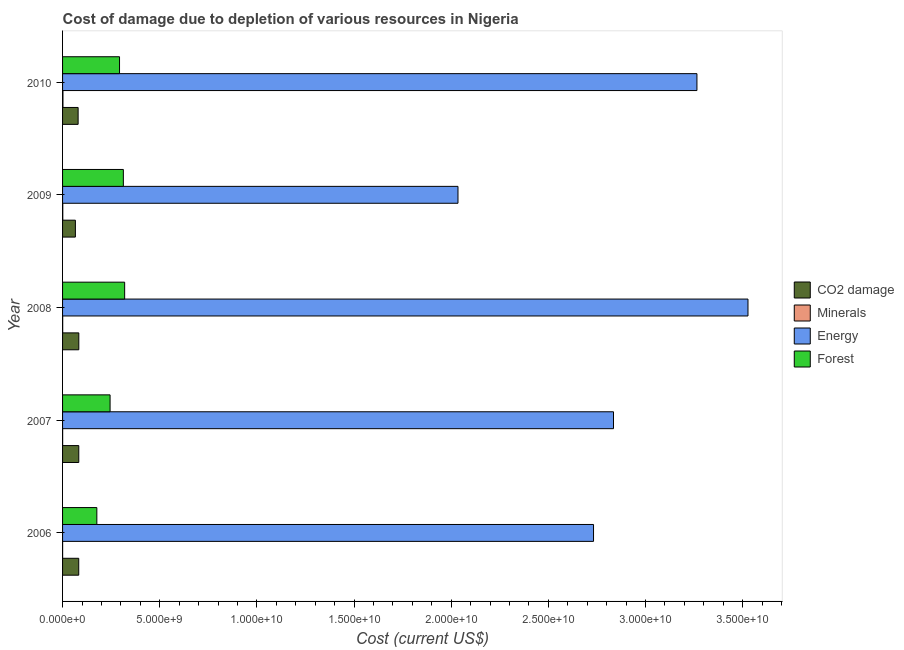Are the number of bars per tick equal to the number of legend labels?
Give a very brief answer. Yes. How many bars are there on the 5th tick from the top?
Provide a succinct answer. 4. What is the label of the 2nd group of bars from the top?
Your response must be concise. 2009. In how many cases, is the number of bars for a given year not equal to the number of legend labels?
Keep it short and to the point. 0. What is the cost of damage due to depletion of coal in 2010?
Your response must be concise. 8.01e+08. Across all years, what is the maximum cost of damage due to depletion of forests?
Ensure brevity in your answer.  3.20e+09. Across all years, what is the minimum cost of damage due to depletion of minerals?
Your response must be concise. 2.15e+06. What is the total cost of damage due to depletion of minerals in the graph?
Offer a terse response. 4.35e+07. What is the difference between the cost of damage due to depletion of minerals in 2007 and that in 2008?
Provide a succinct answer. -2.84e+06. What is the difference between the cost of damage due to depletion of forests in 2010 and the cost of damage due to depletion of minerals in 2009?
Offer a very short reply. 2.92e+09. What is the average cost of damage due to depletion of coal per year?
Give a very brief answer. 7.93e+08. In the year 2006, what is the difference between the cost of damage due to depletion of minerals and cost of damage due to depletion of coal?
Offer a terse response. -8.30e+08. What is the ratio of the cost of damage due to depletion of forests in 2009 to that in 2010?
Offer a terse response. 1.07. Is the cost of damage due to depletion of forests in 2007 less than that in 2009?
Your answer should be very brief. Yes. Is the difference between the cost of damage due to depletion of minerals in 2006 and 2010 greater than the difference between the cost of damage due to depletion of coal in 2006 and 2010?
Your answer should be compact. No. What is the difference between the highest and the second highest cost of damage due to depletion of forests?
Ensure brevity in your answer.  6.72e+07. What is the difference between the highest and the lowest cost of damage due to depletion of forests?
Keep it short and to the point. 1.43e+09. In how many years, is the cost of damage due to depletion of coal greater than the average cost of damage due to depletion of coal taken over all years?
Your answer should be compact. 4. Is it the case that in every year, the sum of the cost of damage due to depletion of coal and cost of damage due to depletion of forests is greater than the sum of cost of damage due to depletion of energy and cost of damage due to depletion of minerals?
Ensure brevity in your answer.  Yes. What does the 1st bar from the top in 2006 represents?
Offer a terse response. Forest. What does the 3rd bar from the bottom in 2010 represents?
Offer a very short reply. Energy. How many bars are there?
Keep it short and to the point. 20. Are all the bars in the graph horizontal?
Your response must be concise. Yes. Does the graph contain any zero values?
Offer a very short reply. No. Where does the legend appear in the graph?
Offer a very short reply. Center right. How many legend labels are there?
Provide a short and direct response. 4. What is the title of the graph?
Give a very brief answer. Cost of damage due to depletion of various resources in Nigeria . What is the label or title of the X-axis?
Provide a succinct answer. Cost (current US$). What is the label or title of the Y-axis?
Ensure brevity in your answer.  Year. What is the Cost (current US$) of CO2 damage in 2006?
Provide a succinct answer. 8.32e+08. What is the Cost (current US$) of Minerals in 2006?
Your response must be concise. 2.15e+06. What is the Cost (current US$) in Energy in 2006?
Provide a succinct answer. 2.73e+1. What is the Cost (current US$) in Forest in 2006?
Your answer should be compact. 1.76e+09. What is the Cost (current US$) of CO2 damage in 2007?
Ensure brevity in your answer.  8.34e+08. What is the Cost (current US$) in Minerals in 2007?
Keep it short and to the point. 3.60e+06. What is the Cost (current US$) in Energy in 2007?
Provide a short and direct response. 2.84e+1. What is the Cost (current US$) of Forest in 2007?
Make the answer very short. 2.45e+09. What is the Cost (current US$) in CO2 damage in 2008?
Make the answer very short. 8.36e+08. What is the Cost (current US$) in Minerals in 2008?
Give a very brief answer. 6.44e+06. What is the Cost (current US$) of Energy in 2008?
Offer a terse response. 3.53e+1. What is the Cost (current US$) in Forest in 2008?
Your answer should be compact. 3.20e+09. What is the Cost (current US$) in CO2 damage in 2009?
Provide a succinct answer. 6.60e+08. What is the Cost (current US$) in Minerals in 2009?
Ensure brevity in your answer.  1.12e+07. What is the Cost (current US$) in Energy in 2009?
Ensure brevity in your answer.  2.03e+1. What is the Cost (current US$) in Forest in 2009?
Your answer should be compact. 3.13e+09. What is the Cost (current US$) in CO2 damage in 2010?
Ensure brevity in your answer.  8.01e+08. What is the Cost (current US$) in Minerals in 2010?
Your answer should be compact. 2.01e+07. What is the Cost (current US$) of Energy in 2010?
Provide a short and direct response. 3.26e+1. What is the Cost (current US$) in Forest in 2010?
Provide a short and direct response. 2.93e+09. Across all years, what is the maximum Cost (current US$) in CO2 damage?
Offer a terse response. 8.36e+08. Across all years, what is the maximum Cost (current US$) in Minerals?
Give a very brief answer. 2.01e+07. Across all years, what is the maximum Cost (current US$) in Energy?
Your answer should be compact. 3.53e+1. Across all years, what is the maximum Cost (current US$) in Forest?
Make the answer very short. 3.20e+09. Across all years, what is the minimum Cost (current US$) in CO2 damage?
Offer a very short reply. 6.60e+08. Across all years, what is the minimum Cost (current US$) of Minerals?
Offer a terse response. 2.15e+06. Across all years, what is the minimum Cost (current US$) in Energy?
Offer a very short reply. 2.03e+1. Across all years, what is the minimum Cost (current US$) of Forest?
Provide a succinct answer. 1.76e+09. What is the total Cost (current US$) of CO2 damage in the graph?
Offer a very short reply. 3.96e+09. What is the total Cost (current US$) of Minerals in the graph?
Offer a very short reply. 4.35e+07. What is the total Cost (current US$) of Energy in the graph?
Offer a very short reply. 1.44e+11. What is the total Cost (current US$) in Forest in the graph?
Your answer should be compact. 1.35e+1. What is the difference between the Cost (current US$) in CO2 damage in 2006 and that in 2007?
Make the answer very short. -2.52e+06. What is the difference between the Cost (current US$) in Minerals in 2006 and that in 2007?
Make the answer very short. -1.45e+06. What is the difference between the Cost (current US$) of Energy in 2006 and that in 2007?
Your response must be concise. -1.03e+09. What is the difference between the Cost (current US$) of Forest in 2006 and that in 2007?
Ensure brevity in your answer.  -6.82e+08. What is the difference between the Cost (current US$) in CO2 damage in 2006 and that in 2008?
Your answer should be compact. -4.67e+06. What is the difference between the Cost (current US$) in Minerals in 2006 and that in 2008?
Your response must be concise. -4.29e+06. What is the difference between the Cost (current US$) in Energy in 2006 and that in 2008?
Your response must be concise. -7.95e+09. What is the difference between the Cost (current US$) in Forest in 2006 and that in 2008?
Provide a short and direct response. -1.43e+09. What is the difference between the Cost (current US$) of CO2 damage in 2006 and that in 2009?
Keep it short and to the point. 1.72e+08. What is the difference between the Cost (current US$) in Minerals in 2006 and that in 2009?
Your response must be concise. -9.04e+06. What is the difference between the Cost (current US$) of Energy in 2006 and that in 2009?
Offer a terse response. 6.98e+09. What is the difference between the Cost (current US$) in Forest in 2006 and that in 2009?
Offer a very short reply. -1.36e+09. What is the difference between the Cost (current US$) in CO2 damage in 2006 and that in 2010?
Offer a very short reply. 3.08e+07. What is the difference between the Cost (current US$) of Minerals in 2006 and that in 2010?
Your answer should be compact. -1.80e+07. What is the difference between the Cost (current US$) of Energy in 2006 and that in 2010?
Provide a succinct answer. -5.32e+09. What is the difference between the Cost (current US$) of Forest in 2006 and that in 2010?
Keep it short and to the point. -1.17e+09. What is the difference between the Cost (current US$) in CO2 damage in 2007 and that in 2008?
Offer a terse response. -2.15e+06. What is the difference between the Cost (current US$) in Minerals in 2007 and that in 2008?
Your answer should be compact. -2.84e+06. What is the difference between the Cost (current US$) in Energy in 2007 and that in 2008?
Provide a short and direct response. -6.92e+09. What is the difference between the Cost (current US$) of Forest in 2007 and that in 2008?
Offer a very short reply. -7.50e+08. What is the difference between the Cost (current US$) of CO2 damage in 2007 and that in 2009?
Your answer should be compact. 1.75e+08. What is the difference between the Cost (current US$) in Minerals in 2007 and that in 2009?
Offer a terse response. -7.58e+06. What is the difference between the Cost (current US$) of Energy in 2007 and that in 2009?
Your answer should be compact. 8.00e+09. What is the difference between the Cost (current US$) in Forest in 2007 and that in 2009?
Your answer should be compact. -6.83e+08. What is the difference between the Cost (current US$) in CO2 damage in 2007 and that in 2010?
Your answer should be compact. 3.33e+07. What is the difference between the Cost (current US$) of Minerals in 2007 and that in 2010?
Offer a terse response. -1.65e+07. What is the difference between the Cost (current US$) in Energy in 2007 and that in 2010?
Offer a terse response. -4.29e+09. What is the difference between the Cost (current US$) of Forest in 2007 and that in 2010?
Provide a succinct answer. -4.86e+08. What is the difference between the Cost (current US$) of CO2 damage in 2008 and that in 2009?
Your response must be concise. 1.77e+08. What is the difference between the Cost (current US$) in Minerals in 2008 and that in 2009?
Your response must be concise. -4.75e+06. What is the difference between the Cost (current US$) in Energy in 2008 and that in 2009?
Provide a succinct answer. 1.49e+1. What is the difference between the Cost (current US$) of Forest in 2008 and that in 2009?
Your answer should be compact. 6.72e+07. What is the difference between the Cost (current US$) in CO2 damage in 2008 and that in 2010?
Offer a very short reply. 3.55e+07. What is the difference between the Cost (current US$) in Minerals in 2008 and that in 2010?
Your response must be concise. -1.37e+07. What is the difference between the Cost (current US$) in Energy in 2008 and that in 2010?
Give a very brief answer. 2.63e+09. What is the difference between the Cost (current US$) of Forest in 2008 and that in 2010?
Keep it short and to the point. 2.64e+08. What is the difference between the Cost (current US$) in CO2 damage in 2009 and that in 2010?
Provide a short and direct response. -1.41e+08. What is the difference between the Cost (current US$) in Minerals in 2009 and that in 2010?
Provide a short and direct response. -8.95e+06. What is the difference between the Cost (current US$) in Energy in 2009 and that in 2010?
Keep it short and to the point. -1.23e+1. What is the difference between the Cost (current US$) of Forest in 2009 and that in 2010?
Your response must be concise. 1.97e+08. What is the difference between the Cost (current US$) in CO2 damage in 2006 and the Cost (current US$) in Minerals in 2007?
Your answer should be very brief. 8.28e+08. What is the difference between the Cost (current US$) in CO2 damage in 2006 and the Cost (current US$) in Energy in 2007?
Your answer should be very brief. -2.75e+1. What is the difference between the Cost (current US$) in CO2 damage in 2006 and the Cost (current US$) in Forest in 2007?
Keep it short and to the point. -1.61e+09. What is the difference between the Cost (current US$) in Minerals in 2006 and the Cost (current US$) in Energy in 2007?
Offer a terse response. -2.83e+1. What is the difference between the Cost (current US$) of Minerals in 2006 and the Cost (current US$) of Forest in 2007?
Give a very brief answer. -2.44e+09. What is the difference between the Cost (current US$) in Energy in 2006 and the Cost (current US$) in Forest in 2007?
Your answer should be very brief. 2.49e+1. What is the difference between the Cost (current US$) of CO2 damage in 2006 and the Cost (current US$) of Minerals in 2008?
Your answer should be compact. 8.25e+08. What is the difference between the Cost (current US$) in CO2 damage in 2006 and the Cost (current US$) in Energy in 2008?
Offer a terse response. -3.44e+1. What is the difference between the Cost (current US$) in CO2 damage in 2006 and the Cost (current US$) in Forest in 2008?
Offer a terse response. -2.36e+09. What is the difference between the Cost (current US$) of Minerals in 2006 and the Cost (current US$) of Energy in 2008?
Offer a terse response. -3.53e+1. What is the difference between the Cost (current US$) of Minerals in 2006 and the Cost (current US$) of Forest in 2008?
Give a very brief answer. -3.19e+09. What is the difference between the Cost (current US$) of Energy in 2006 and the Cost (current US$) of Forest in 2008?
Provide a short and direct response. 2.41e+1. What is the difference between the Cost (current US$) in CO2 damage in 2006 and the Cost (current US$) in Minerals in 2009?
Offer a very short reply. 8.21e+08. What is the difference between the Cost (current US$) in CO2 damage in 2006 and the Cost (current US$) in Energy in 2009?
Keep it short and to the point. -1.95e+1. What is the difference between the Cost (current US$) of CO2 damage in 2006 and the Cost (current US$) of Forest in 2009?
Your answer should be compact. -2.30e+09. What is the difference between the Cost (current US$) in Minerals in 2006 and the Cost (current US$) in Energy in 2009?
Offer a terse response. -2.03e+1. What is the difference between the Cost (current US$) of Minerals in 2006 and the Cost (current US$) of Forest in 2009?
Offer a terse response. -3.13e+09. What is the difference between the Cost (current US$) in Energy in 2006 and the Cost (current US$) in Forest in 2009?
Make the answer very short. 2.42e+1. What is the difference between the Cost (current US$) in CO2 damage in 2006 and the Cost (current US$) in Minerals in 2010?
Provide a succinct answer. 8.12e+08. What is the difference between the Cost (current US$) in CO2 damage in 2006 and the Cost (current US$) in Energy in 2010?
Keep it short and to the point. -3.18e+1. What is the difference between the Cost (current US$) of CO2 damage in 2006 and the Cost (current US$) of Forest in 2010?
Give a very brief answer. -2.10e+09. What is the difference between the Cost (current US$) in Minerals in 2006 and the Cost (current US$) in Energy in 2010?
Your answer should be very brief. -3.26e+1. What is the difference between the Cost (current US$) in Minerals in 2006 and the Cost (current US$) in Forest in 2010?
Your response must be concise. -2.93e+09. What is the difference between the Cost (current US$) of Energy in 2006 and the Cost (current US$) of Forest in 2010?
Provide a succinct answer. 2.44e+1. What is the difference between the Cost (current US$) in CO2 damage in 2007 and the Cost (current US$) in Minerals in 2008?
Make the answer very short. 8.28e+08. What is the difference between the Cost (current US$) in CO2 damage in 2007 and the Cost (current US$) in Energy in 2008?
Offer a terse response. -3.44e+1. What is the difference between the Cost (current US$) of CO2 damage in 2007 and the Cost (current US$) of Forest in 2008?
Make the answer very short. -2.36e+09. What is the difference between the Cost (current US$) in Minerals in 2007 and the Cost (current US$) in Energy in 2008?
Your response must be concise. -3.53e+1. What is the difference between the Cost (current US$) of Minerals in 2007 and the Cost (current US$) of Forest in 2008?
Provide a short and direct response. -3.19e+09. What is the difference between the Cost (current US$) in Energy in 2007 and the Cost (current US$) in Forest in 2008?
Your answer should be compact. 2.52e+1. What is the difference between the Cost (current US$) of CO2 damage in 2007 and the Cost (current US$) of Minerals in 2009?
Offer a very short reply. 8.23e+08. What is the difference between the Cost (current US$) in CO2 damage in 2007 and the Cost (current US$) in Energy in 2009?
Ensure brevity in your answer.  -1.95e+1. What is the difference between the Cost (current US$) in CO2 damage in 2007 and the Cost (current US$) in Forest in 2009?
Keep it short and to the point. -2.29e+09. What is the difference between the Cost (current US$) of Minerals in 2007 and the Cost (current US$) of Energy in 2009?
Your response must be concise. -2.03e+1. What is the difference between the Cost (current US$) in Minerals in 2007 and the Cost (current US$) in Forest in 2009?
Your answer should be compact. -3.12e+09. What is the difference between the Cost (current US$) in Energy in 2007 and the Cost (current US$) in Forest in 2009?
Keep it short and to the point. 2.52e+1. What is the difference between the Cost (current US$) in CO2 damage in 2007 and the Cost (current US$) in Minerals in 2010?
Offer a terse response. 8.14e+08. What is the difference between the Cost (current US$) of CO2 damage in 2007 and the Cost (current US$) of Energy in 2010?
Offer a terse response. -3.18e+1. What is the difference between the Cost (current US$) of CO2 damage in 2007 and the Cost (current US$) of Forest in 2010?
Offer a very short reply. -2.10e+09. What is the difference between the Cost (current US$) of Minerals in 2007 and the Cost (current US$) of Energy in 2010?
Provide a succinct answer. -3.26e+1. What is the difference between the Cost (current US$) of Minerals in 2007 and the Cost (current US$) of Forest in 2010?
Offer a terse response. -2.93e+09. What is the difference between the Cost (current US$) of Energy in 2007 and the Cost (current US$) of Forest in 2010?
Your answer should be very brief. 2.54e+1. What is the difference between the Cost (current US$) in CO2 damage in 2008 and the Cost (current US$) in Minerals in 2009?
Your answer should be compact. 8.25e+08. What is the difference between the Cost (current US$) in CO2 damage in 2008 and the Cost (current US$) in Energy in 2009?
Keep it short and to the point. -1.95e+1. What is the difference between the Cost (current US$) in CO2 damage in 2008 and the Cost (current US$) in Forest in 2009?
Ensure brevity in your answer.  -2.29e+09. What is the difference between the Cost (current US$) in Minerals in 2008 and the Cost (current US$) in Energy in 2009?
Your response must be concise. -2.03e+1. What is the difference between the Cost (current US$) in Minerals in 2008 and the Cost (current US$) in Forest in 2009?
Provide a short and direct response. -3.12e+09. What is the difference between the Cost (current US$) of Energy in 2008 and the Cost (current US$) of Forest in 2009?
Keep it short and to the point. 3.21e+1. What is the difference between the Cost (current US$) of CO2 damage in 2008 and the Cost (current US$) of Minerals in 2010?
Ensure brevity in your answer.  8.16e+08. What is the difference between the Cost (current US$) in CO2 damage in 2008 and the Cost (current US$) in Energy in 2010?
Your response must be concise. -3.18e+1. What is the difference between the Cost (current US$) in CO2 damage in 2008 and the Cost (current US$) in Forest in 2010?
Offer a very short reply. -2.09e+09. What is the difference between the Cost (current US$) in Minerals in 2008 and the Cost (current US$) in Energy in 2010?
Provide a succinct answer. -3.26e+1. What is the difference between the Cost (current US$) in Minerals in 2008 and the Cost (current US$) in Forest in 2010?
Your answer should be very brief. -2.92e+09. What is the difference between the Cost (current US$) in Energy in 2008 and the Cost (current US$) in Forest in 2010?
Give a very brief answer. 3.23e+1. What is the difference between the Cost (current US$) in CO2 damage in 2009 and the Cost (current US$) in Minerals in 2010?
Your response must be concise. 6.39e+08. What is the difference between the Cost (current US$) in CO2 damage in 2009 and the Cost (current US$) in Energy in 2010?
Your response must be concise. -3.20e+1. What is the difference between the Cost (current US$) in CO2 damage in 2009 and the Cost (current US$) in Forest in 2010?
Provide a short and direct response. -2.27e+09. What is the difference between the Cost (current US$) of Minerals in 2009 and the Cost (current US$) of Energy in 2010?
Your answer should be very brief. -3.26e+1. What is the difference between the Cost (current US$) of Minerals in 2009 and the Cost (current US$) of Forest in 2010?
Your answer should be compact. -2.92e+09. What is the difference between the Cost (current US$) in Energy in 2009 and the Cost (current US$) in Forest in 2010?
Offer a terse response. 1.74e+1. What is the average Cost (current US$) in CO2 damage per year?
Give a very brief answer. 7.93e+08. What is the average Cost (current US$) in Minerals per year?
Offer a very short reply. 8.70e+06. What is the average Cost (current US$) of Energy per year?
Your answer should be very brief. 2.88e+1. What is the average Cost (current US$) of Forest per year?
Provide a short and direct response. 2.69e+09. In the year 2006, what is the difference between the Cost (current US$) in CO2 damage and Cost (current US$) in Minerals?
Provide a short and direct response. 8.30e+08. In the year 2006, what is the difference between the Cost (current US$) of CO2 damage and Cost (current US$) of Energy?
Provide a short and direct response. -2.65e+1. In the year 2006, what is the difference between the Cost (current US$) in CO2 damage and Cost (current US$) in Forest?
Provide a short and direct response. -9.32e+08. In the year 2006, what is the difference between the Cost (current US$) in Minerals and Cost (current US$) in Energy?
Offer a very short reply. -2.73e+1. In the year 2006, what is the difference between the Cost (current US$) in Minerals and Cost (current US$) in Forest?
Your answer should be very brief. -1.76e+09. In the year 2006, what is the difference between the Cost (current US$) of Energy and Cost (current US$) of Forest?
Give a very brief answer. 2.56e+1. In the year 2007, what is the difference between the Cost (current US$) of CO2 damage and Cost (current US$) of Minerals?
Your answer should be very brief. 8.31e+08. In the year 2007, what is the difference between the Cost (current US$) of CO2 damage and Cost (current US$) of Energy?
Your answer should be very brief. -2.75e+1. In the year 2007, what is the difference between the Cost (current US$) of CO2 damage and Cost (current US$) of Forest?
Make the answer very short. -1.61e+09. In the year 2007, what is the difference between the Cost (current US$) of Minerals and Cost (current US$) of Energy?
Your answer should be very brief. -2.83e+1. In the year 2007, what is the difference between the Cost (current US$) in Minerals and Cost (current US$) in Forest?
Offer a very short reply. -2.44e+09. In the year 2007, what is the difference between the Cost (current US$) in Energy and Cost (current US$) in Forest?
Your answer should be very brief. 2.59e+1. In the year 2008, what is the difference between the Cost (current US$) in CO2 damage and Cost (current US$) in Minerals?
Your answer should be compact. 8.30e+08. In the year 2008, what is the difference between the Cost (current US$) of CO2 damage and Cost (current US$) of Energy?
Offer a terse response. -3.44e+1. In the year 2008, what is the difference between the Cost (current US$) of CO2 damage and Cost (current US$) of Forest?
Make the answer very short. -2.36e+09. In the year 2008, what is the difference between the Cost (current US$) in Minerals and Cost (current US$) in Energy?
Your response must be concise. -3.53e+1. In the year 2008, what is the difference between the Cost (current US$) of Minerals and Cost (current US$) of Forest?
Offer a terse response. -3.19e+09. In the year 2008, what is the difference between the Cost (current US$) in Energy and Cost (current US$) in Forest?
Ensure brevity in your answer.  3.21e+1. In the year 2009, what is the difference between the Cost (current US$) of CO2 damage and Cost (current US$) of Minerals?
Your answer should be very brief. 6.48e+08. In the year 2009, what is the difference between the Cost (current US$) of CO2 damage and Cost (current US$) of Energy?
Keep it short and to the point. -1.97e+1. In the year 2009, what is the difference between the Cost (current US$) of CO2 damage and Cost (current US$) of Forest?
Give a very brief answer. -2.47e+09. In the year 2009, what is the difference between the Cost (current US$) of Minerals and Cost (current US$) of Energy?
Offer a terse response. -2.03e+1. In the year 2009, what is the difference between the Cost (current US$) in Minerals and Cost (current US$) in Forest?
Your answer should be compact. -3.12e+09. In the year 2009, what is the difference between the Cost (current US$) of Energy and Cost (current US$) of Forest?
Your answer should be very brief. 1.72e+1. In the year 2010, what is the difference between the Cost (current US$) of CO2 damage and Cost (current US$) of Minerals?
Keep it short and to the point. 7.81e+08. In the year 2010, what is the difference between the Cost (current US$) in CO2 damage and Cost (current US$) in Energy?
Make the answer very short. -3.18e+1. In the year 2010, what is the difference between the Cost (current US$) of CO2 damage and Cost (current US$) of Forest?
Offer a very short reply. -2.13e+09. In the year 2010, what is the difference between the Cost (current US$) of Minerals and Cost (current US$) of Energy?
Make the answer very short. -3.26e+1. In the year 2010, what is the difference between the Cost (current US$) of Minerals and Cost (current US$) of Forest?
Offer a terse response. -2.91e+09. In the year 2010, what is the difference between the Cost (current US$) of Energy and Cost (current US$) of Forest?
Give a very brief answer. 2.97e+1. What is the ratio of the Cost (current US$) in CO2 damage in 2006 to that in 2007?
Your answer should be very brief. 1. What is the ratio of the Cost (current US$) of Minerals in 2006 to that in 2007?
Provide a succinct answer. 0.6. What is the ratio of the Cost (current US$) in Energy in 2006 to that in 2007?
Ensure brevity in your answer.  0.96. What is the ratio of the Cost (current US$) in Forest in 2006 to that in 2007?
Your response must be concise. 0.72. What is the ratio of the Cost (current US$) of Minerals in 2006 to that in 2008?
Give a very brief answer. 0.33. What is the ratio of the Cost (current US$) of Energy in 2006 to that in 2008?
Ensure brevity in your answer.  0.77. What is the ratio of the Cost (current US$) in Forest in 2006 to that in 2008?
Ensure brevity in your answer.  0.55. What is the ratio of the Cost (current US$) in CO2 damage in 2006 to that in 2009?
Keep it short and to the point. 1.26. What is the ratio of the Cost (current US$) in Minerals in 2006 to that in 2009?
Ensure brevity in your answer.  0.19. What is the ratio of the Cost (current US$) of Energy in 2006 to that in 2009?
Keep it short and to the point. 1.34. What is the ratio of the Cost (current US$) of Forest in 2006 to that in 2009?
Offer a very short reply. 0.56. What is the ratio of the Cost (current US$) of CO2 damage in 2006 to that in 2010?
Your answer should be compact. 1.04. What is the ratio of the Cost (current US$) in Minerals in 2006 to that in 2010?
Your answer should be very brief. 0.11. What is the ratio of the Cost (current US$) of Energy in 2006 to that in 2010?
Ensure brevity in your answer.  0.84. What is the ratio of the Cost (current US$) of Forest in 2006 to that in 2010?
Ensure brevity in your answer.  0.6. What is the ratio of the Cost (current US$) of CO2 damage in 2007 to that in 2008?
Provide a succinct answer. 1. What is the ratio of the Cost (current US$) of Minerals in 2007 to that in 2008?
Ensure brevity in your answer.  0.56. What is the ratio of the Cost (current US$) of Energy in 2007 to that in 2008?
Offer a very short reply. 0.8. What is the ratio of the Cost (current US$) of Forest in 2007 to that in 2008?
Provide a succinct answer. 0.77. What is the ratio of the Cost (current US$) in CO2 damage in 2007 to that in 2009?
Provide a succinct answer. 1.26. What is the ratio of the Cost (current US$) in Minerals in 2007 to that in 2009?
Provide a short and direct response. 0.32. What is the ratio of the Cost (current US$) of Energy in 2007 to that in 2009?
Provide a short and direct response. 1.39. What is the ratio of the Cost (current US$) of Forest in 2007 to that in 2009?
Provide a short and direct response. 0.78. What is the ratio of the Cost (current US$) in CO2 damage in 2007 to that in 2010?
Give a very brief answer. 1.04. What is the ratio of the Cost (current US$) of Minerals in 2007 to that in 2010?
Keep it short and to the point. 0.18. What is the ratio of the Cost (current US$) of Energy in 2007 to that in 2010?
Provide a short and direct response. 0.87. What is the ratio of the Cost (current US$) of Forest in 2007 to that in 2010?
Your answer should be very brief. 0.83. What is the ratio of the Cost (current US$) of CO2 damage in 2008 to that in 2009?
Provide a succinct answer. 1.27. What is the ratio of the Cost (current US$) in Minerals in 2008 to that in 2009?
Give a very brief answer. 0.58. What is the ratio of the Cost (current US$) of Energy in 2008 to that in 2009?
Your response must be concise. 1.73. What is the ratio of the Cost (current US$) in Forest in 2008 to that in 2009?
Make the answer very short. 1.02. What is the ratio of the Cost (current US$) of CO2 damage in 2008 to that in 2010?
Offer a very short reply. 1.04. What is the ratio of the Cost (current US$) of Minerals in 2008 to that in 2010?
Your answer should be very brief. 0.32. What is the ratio of the Cost (current US$) of Energy in 2008 to that in 2010?
Offer a terse response. 1.08. What is the ratio of the Cost (current US$) in Forest in 2008 to that in 2010?
Your answer should be very brief. 1.09. What is the ratio of the Cost (current US$) in CO2 damage in 2009 to that in 2010?
Offer a very short reply. 0.82. What is the ratio of the Cost (current US$) in Minerals in 2009 to that in 2010?
Give a very brief answer. 0.56. What is the ratio of the Cost (current US$) in Energy in 2009 to that in 2010?
Give a very brief answer. 0.62. What is the ratio of the Cost (current US$) of Forest in 2009 to that in 2010?
Provide a succinct answer. 1.07. What is the difference between the highest and the second highest Cost (current US$) of CO2 damage?
Your answer should be compact. 2.15e+06. What is the difference between the highest and the second highest Cost (current US$) of Minerals?
Your answer should be compact. 8.95e+06. What is the difference between the highest and the second highest Cost (current US$) in Energy?
Make the answer very short. 2.63e+09. What is the difference between the highest and the second highest Cost (current US$) of Forest?
Offer a terse response. 6.72e+07. What is the difference between the highest and the lowest Cost (current US$) of CO2 damage?
Your answer should be compact. 1.77e+08. What is the difference between the highest and the lowest Cost (current US$) of Minerals?
Give a very brief answer. 1.80e+07. What is the difference between the highest and the lowest Cost (current US$) of Energy?
Your answer should be very brief. 1.49e+1. What is the difference between the highest and the lowest Cost (current US$) in Forest?
Make the answer very short. 1.43e+09. 